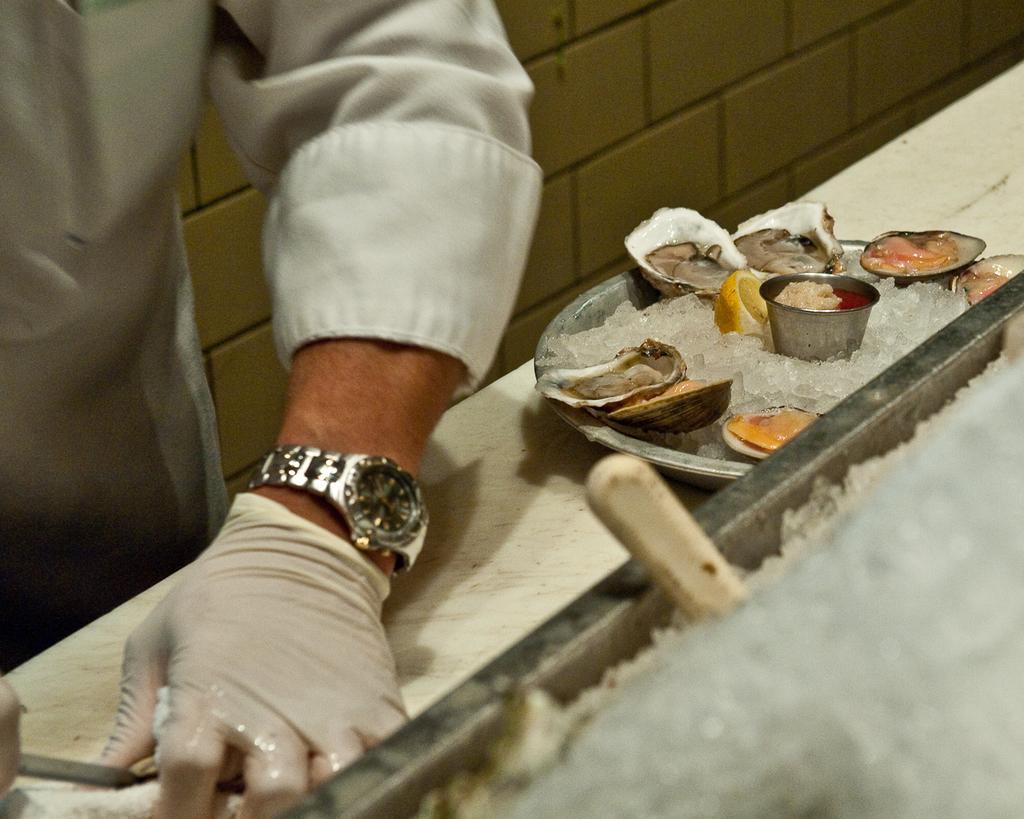Describe this image in one or two sentences. In this picture we can see a man, he wore a glove, in front of him we can find ice and few other things in the plate, and we can see a wristwatch. 